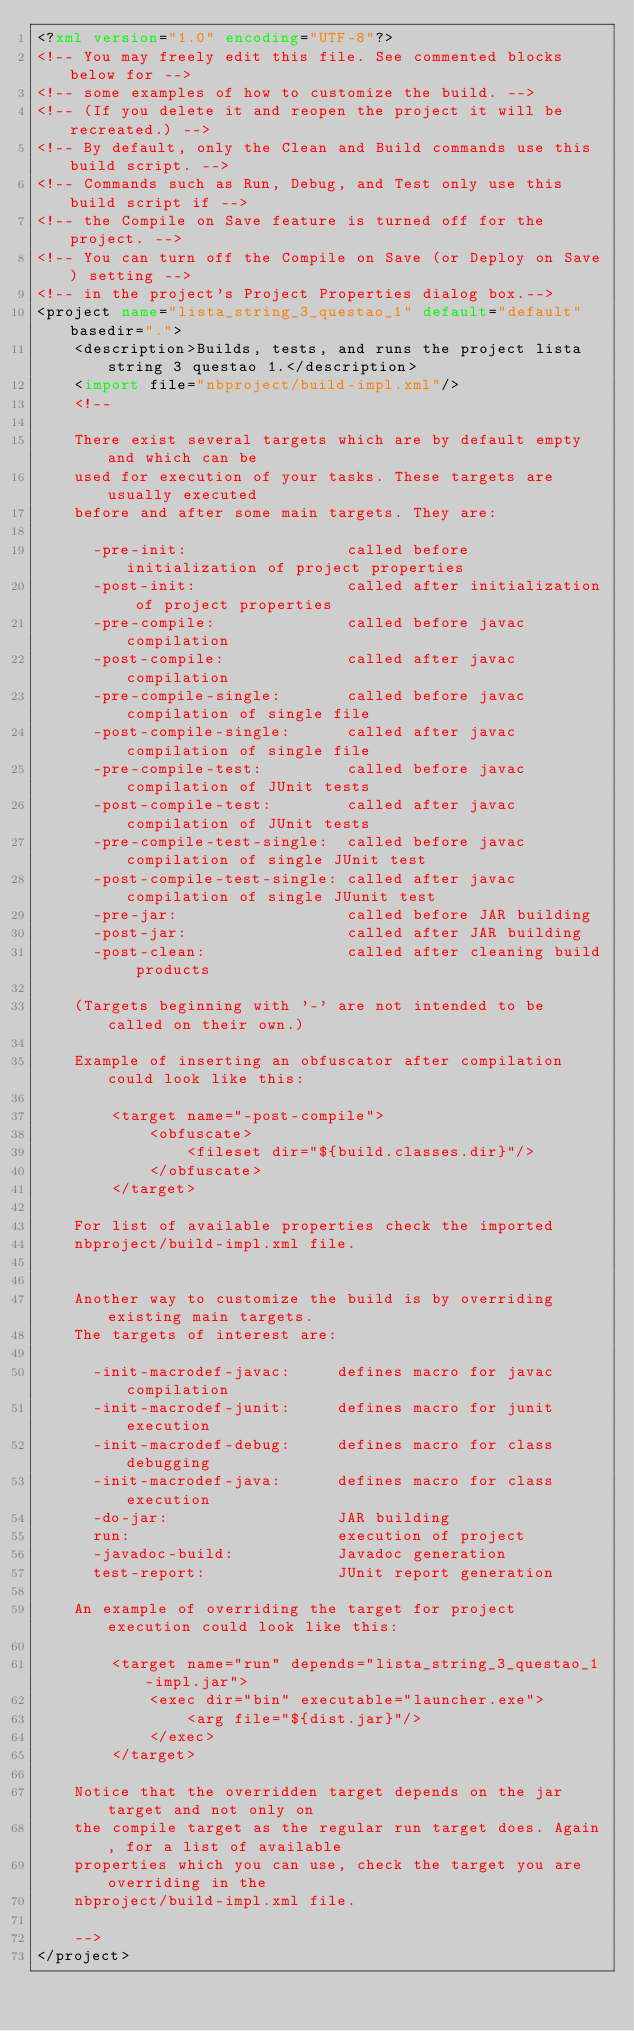<code> <loc_0><loc_0><loc_500><loc_500><_XML_><?xml version="1.0" encoding="UTF-8"?>
<!-- You may freely edit this file. See commented blocks below for -->
<!-- some examples of how to customize the build. -->
<!-- (If you delete it and reopen the project it will be recreated.) -->
<!-- By default, only the Clean and Build commands use this build script. -->
<!-- Commands such as Run, Debug, and Test only use this build script if -->
<!-- the Compile on Save feature is turned off for the project. -->
<!-- You can turn off the Compile on Save (or Deploy on Save) setting -->
<!-- in the project's Project Properties dialog box.-->
<project name="lista_string_3_questao_1" default="default" basedir=".">
    <description>Builds, tests, and runs the project lista string 3 questao 1.</description>
    <import file="nbproject/build-impl.xml"/>
    <!--

    There exist several targets which are by default empty and which can be 
    used for execution of your tasks. These targets are usually executed 
    before and after some main targets. They are: 

      -pre-init:                 called before initialization of project properties
      -post-init:                called after initialization of project properties
      -pre-compile:              called before javac compilation
      -post-compile:             called after javac compilation
      -pre-compile-single:       called before javac compilation of single file
      -post-compile-single:      called after javac compilation of single file
      -pre-compile-test:         called before javac compilation of JUnit tests
      -post-compile-test:        called after javac compilation of JUnit tests
      -pre-compile-test-single:  called before javac compilation of single JUnit test
      -post-compile-test-single: called after javac compilation of single JUunit test
      -pre-jar:                  called before JAR building
      -post-jar:                 called after JAR building
      -post-clean:               called after cleaning build products

    (Targets beginning with '-' are not intended to be called on their own.)

    Example of inserting an obfuscator after compilation could look like this:

        <target name="-post-compile">
            <obfuscate>
                <fileset dir="${build.classes.dir}"/>
            </obfuscate>
        </target>

    For list of available properties check the imported 
    nbproject/build-impl.xml file. 


    Another way to customize the build is by overriding existing main targets.
    The targets of interest are: 

      -init-macrodef-javac:     defines macro for javac compilation
      -init-macrodef-junit:     defines macro for junit execution
      -init-macrodef-debug:     defines macro for class debugging
      -init-macrodef-java:      defines macro for class execution
      -do-jar:                  JAR building
      run:                      execution of project 
      -javadoc-build:           Javadoc generation
      test-report:              JUnit report generation

    An example of overriding the target for project execution could look like this:

        <target name="run" depends="lista_string_3_questao_1-impl.jar">
            <exec dir="bin" executable="launcher.exe">
                <arg file="${dist.jar}"/>
            </exec>
        </target>

    Notice that the overridden target depends on the jar target and not only on 
    the compile target as the regular run target does. Again, for a list of available 
    properties which you can use, check the target you are overriding in the
    nbproject/build-impl.xml file. 

    -->
</project>
</code> 